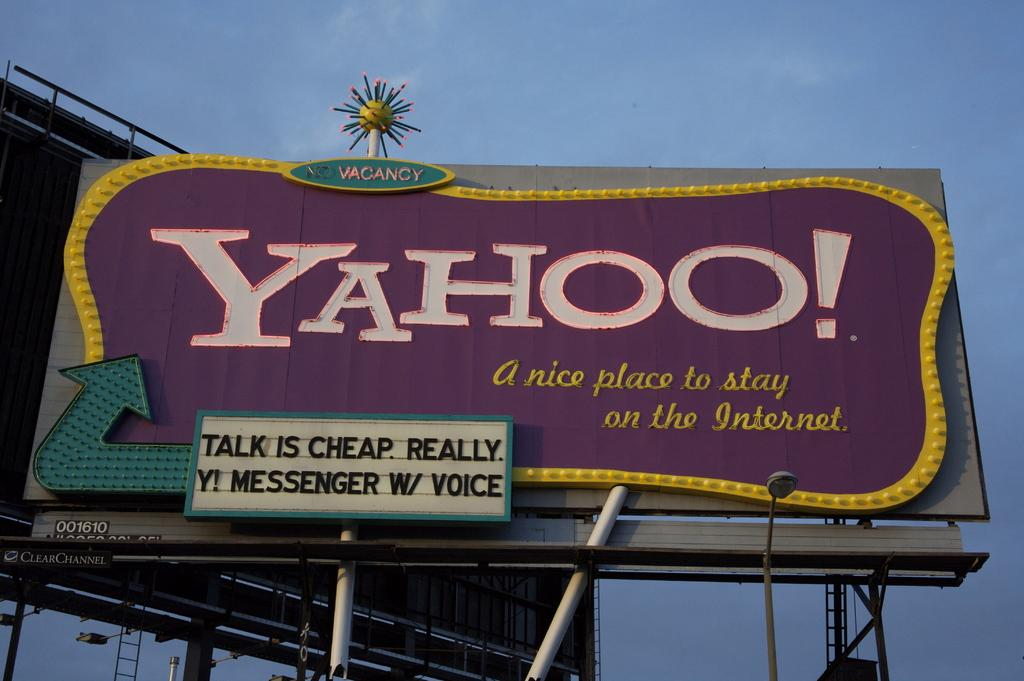<image>
Render a clear and concise summary of the photo. A large sign informs of vacancy at a place called Yahoo. 